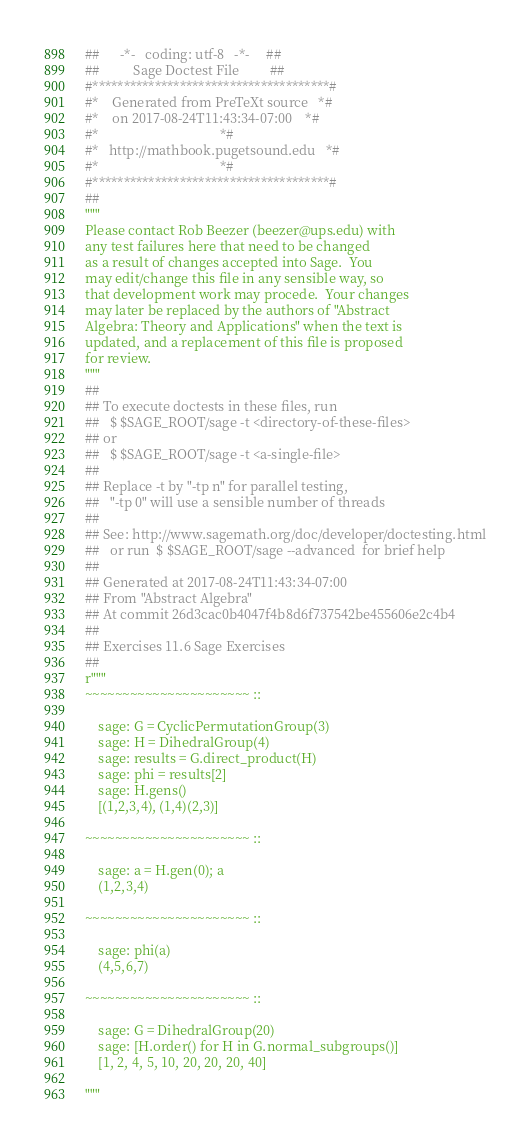<code> <loc_0><loc_0><loc_500><loc_500><_Python_>##      -*-   coding: utf-8   -*-     ##
##          Sage Doctest File         ##
#**************************************#
#*    Generated from PreTeXt source   *#
#*    on 2017-08-24T11:43:34-07:00    *#
#*                                    *#
#*   http://mathbook.pugetsound.edu   *#
#*                                    *#
#**************************************#
##
"""
Please contact Rob Beezer (beezer@ups.edu) with
any test failures here that need to be changed
as a result of changes accepted into Sage.  You
may edit/change this file in any sensible way, so
that development work may procede.  Your changes
may later be replaced by the authors of "Abstract
Algebra: Theory and Applications" when the text is
updated, and a replacement of this file is proposed
for review.
"""
##
## To execute doctests in these files, run
##   $ $SAGE_ROOT/sage -t <directory-of-these-files>
## or
##   $ $SAGE_ROOT/sage -t <a-single-file>
##
## Replace -t by "-tp n" for parallel testing,
##   "-tp 0" will use a sensible number of threads
##
## See: http://www.sagemath.org/doc/developer/doctesting.html
##   or run  $ $SAGE_ROOT/sage --advanced  for brief help
##
## Generated at 2017-08-24T11:43:34-07:00
## From "Abstract Algebra"
## At commit 26d3cac0b4047f4b8d6f737542be455606e2c4b4
##
## Exercises 11.6 Sage Exercises
##
r"""
~~~~~~~~~~~~~~~~~~~~~~ ::

    sage: G = CyclicPermutationGroup(3)
    sage: H = DihedralGroup(4)
    sage: results = G.direct_product(H)
    sage: phi = results[2]
    sage: H.gens()
    [(1,2,3,4), (1,4)(2,3)]

~~~~~~~~~~~~~~~~~~~~~~ ::

    sage: a = H.gen(0); a
    (1,2,3,4)

~~~~~~~~~~~~~~~~~~~~~~ ::

    sage: phi(a)
    (4,5,6,7)

~~~~~~~~~~~~~~~~~~~~~~ ::

    sage: G = DihedralGroup(20)
    sage: [H.order() for H in G.normal_subgroups()]
    [1, 2, 4, 5, 10, 20, 20, 20, 40]

"""
</code> 